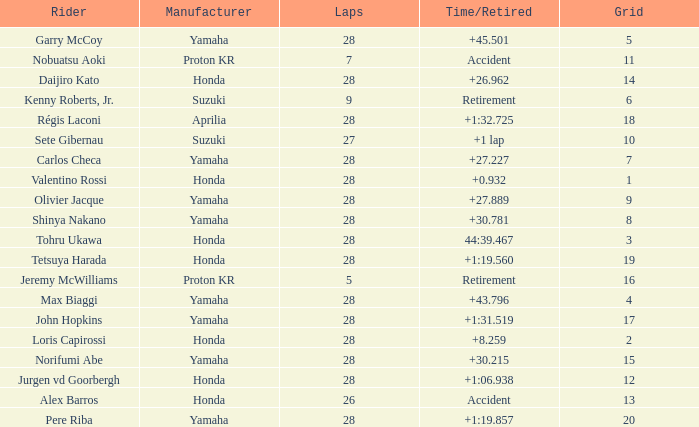Who manufactured grid 11? Proton KR. 